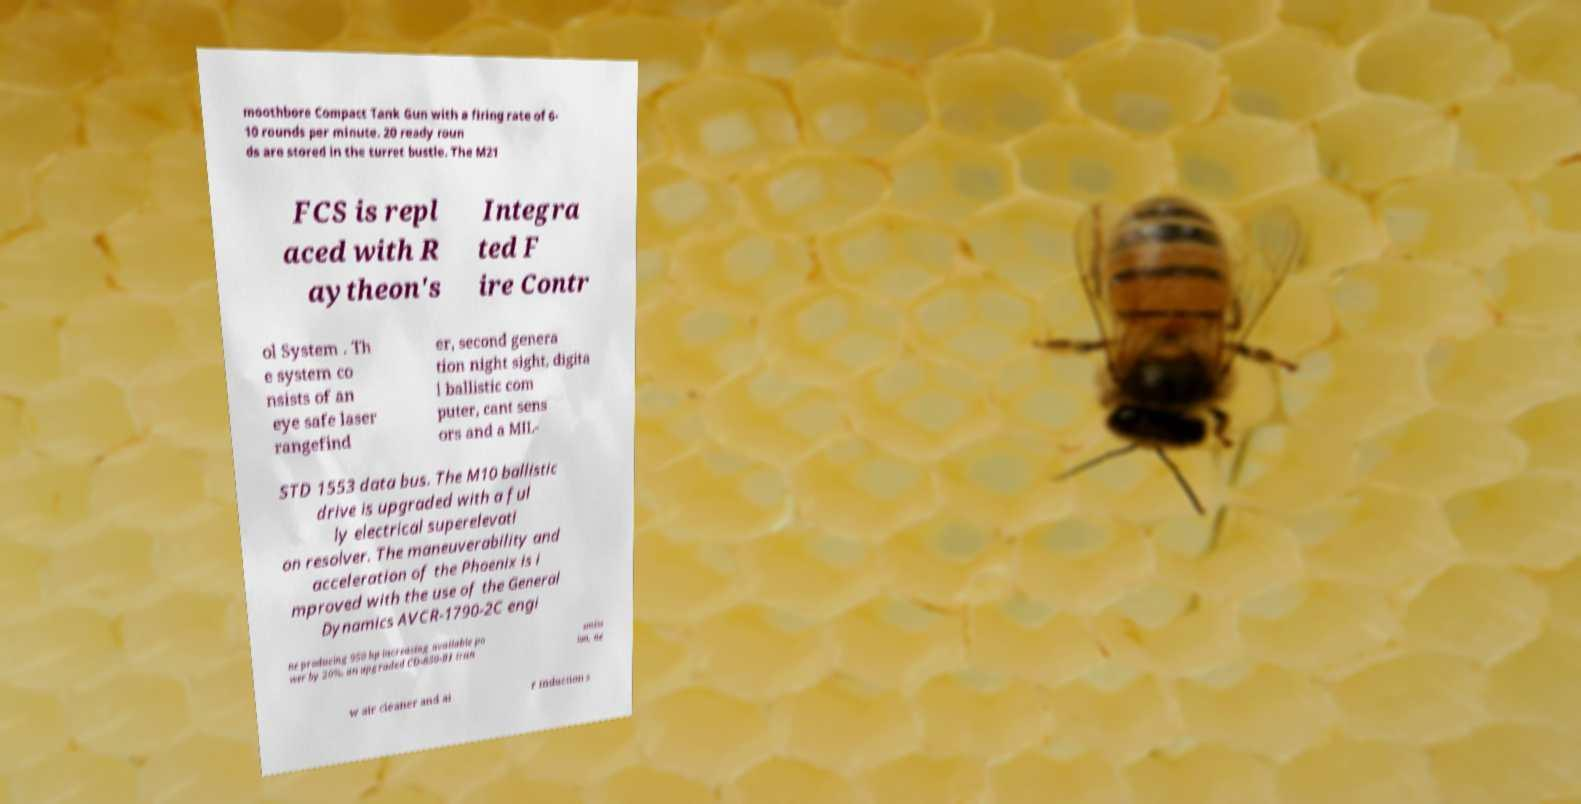Please identify and transcribe the text found in this image. moothbore Compact Tank Gun with a firing rate of 6- 10 rounds per minute. 20 ready roun ds are stored in the turret bustle. The M21 FCS is repl aced with R aytheon's Integra ted F ire Contr ol System . Th e system co nsists of an eye safe laser rangefind er, second genera tion night sight, digita l ballistic com puter, cant sens ors and a MIL- STD 1553 data bus. The M10 ballistic drive is upgraded with a ful ly electrical superelevati on resolver. The maneuverability and acceleration of the Phoenix is i mproved with the use of the General Dynamics AVCR-1790-2C engi ne producing 950 hp increasing available po wer by 20%, an upgraded CD-850-B1 tran smiss ion, ne w air cleaner and ai r induction s 